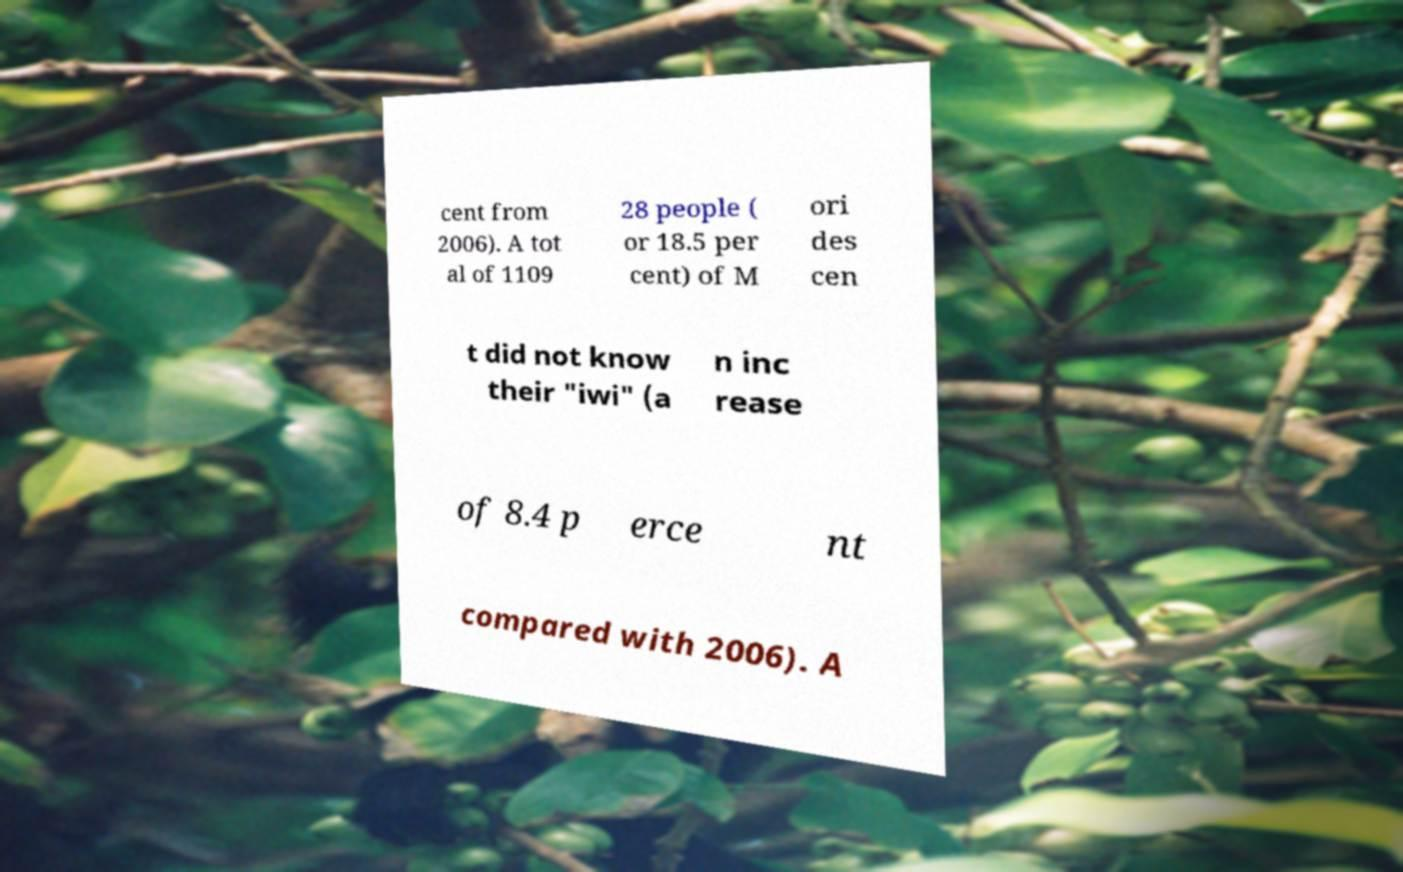Can you accurately transcribe the text from the provided image for me? cent from 2006). A tot al of 1109 28 people ( or 18.5 per cent) of M ori des cen t did not know their "iwi" (a n inc rease of 8.4 p erce nt compared with 2006). A 